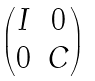Convert formula to latex. <formula><loc_0><loc_0><loc_500><loc_500>\begin{pmatrix} I & 0 \\ 0 & C \end{pmatrix}</formula> 